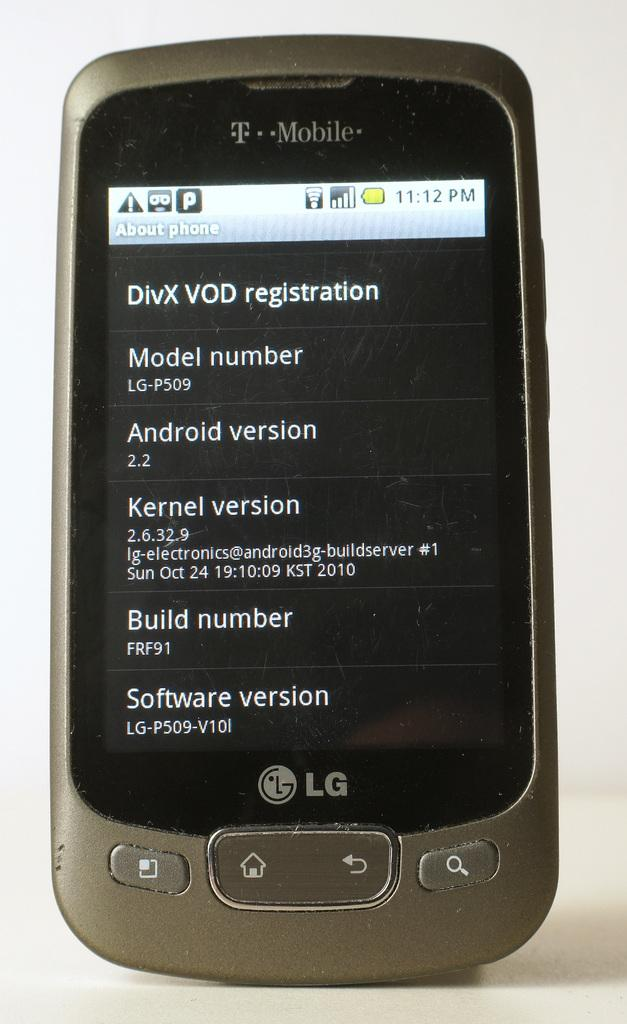Provide a one-sentence caption for the provided image. a T Mobile cell phone with a screen on DivX Vod registration. 